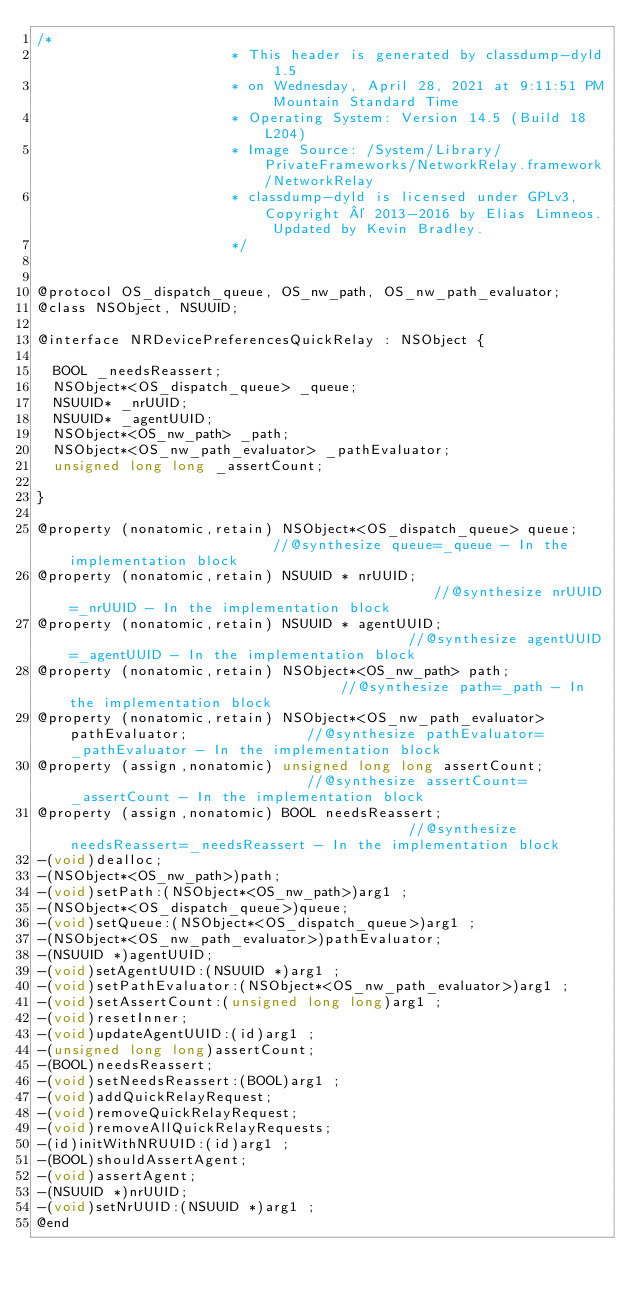<code> <loc_0><loc_0><loc_500><loc_500><_C_>/*
                       * This header is generated by classdump-dyld 1.5
                       * on Wednesday, April 28, 2021 at 9:11:51 PM Mountain Standard Time
                       * Operating System: Version 14.5 (Build 18L204)
                       * Image Source: /System/Library/PrivateFrameworks/NetworkRelay.framework/NetworkRelay
                       * classdump-dyld is licensed under GPLv3, Copyright © 2013-2016 by Elias Limneos. Updated by Kevin Bradley.
                       */


@protocol OS_dispatch_queue, OS_nw_path, OS_nw_path_evaluator;
@class NSObject, NSUUID;

@interface NRDevicePreferencesQuickRelay : NSObject {

	BOOL _needsReassert;
	NSObject*<OS_dispatch_queue> _queue;
	NSUUID* _nrUUID;
	NSUUID* _agentUUID;
	NSObject*<OS_nw_path> _path;
	NSObject*<OS_nw_path_evaluator> _pathEvaluator;
	unsigned long long _assertCount;

}

@property (nonatomic,retain) NSObject*<OS_dispatch_queue> queue;                         //@synthesize queue=_queue - In the implementation block
@property (nonatomic,retain) NSUUID * nrUUID;                                            //@synthesize nrUUID=_nrUUID - In the implementation block
@property (nonatomic,retain) NSUUID * agentUUID;                                         //@synthesize agentUUID=_agentUUID - In the implementation block
@property (nonatomic,retain) NSObject*<OS_nw_path> path;                                 //@synthesize path=_path - In the implementation block
@property (nonatomic,retain) NSObject*<OS_nw_path_evaluator> pathEvaluator;              //@synthesize pathEvaluator=_pathEvaluator - In the implementation block
@property (assign,nonatomic) unsigned long long assertCount;                             //@synthesize assertCount=_assertCount - In the implementation block
@property (assign,nonatomic) BOOL needsReassert;                                         //@synthesize needsReassert=_needsReassert - In the implementation block
-(void)dealloc;
-(NSObject*<OS_nw_path>)path;
-(void)setPath:(NSObject*<OS_nw_path>)arg1 ;
-(NSObject*<OS_dispatch_queue>)queue;
-(void)setQueue:(NSObject*<OS_dispatch_queue>)arg1 ;
-(NSObject*<OS_nw_path_evaluator>)pathEvaluator;
-(NSUUID *)agentUUID;
-(void)setAgentUUID:(NSUUID *)arg1 ;
-(void)setPathEvaluator:(NSObject*<OS_nw_path_evaluator>)arg1 ;
-(void)setAssertCount:(unsigned long long)arg1 ;
-(void)resetInner;
-(void)updateAgentUUID:(id)arg1 ;
-(unsigned long long)assertCount;
-(BOOL)needsReassert;
-(void)setNeedsReassert:(BOOL)arg1 ;
-(void)addQuickRelayRequest;
-(void)removeQuickRelayRequest;
-(void)removeAllQuickRelayRequests;
-(id)initWithNRUUID:(id)arg1 ;
-(BOOL)shouldAssertAgent;
-(void)assertAgent;
-(NSUUID *)nrUUID;
-(void)setNrUUID:(NSUUID *)arg1 ;
@end

</code> 